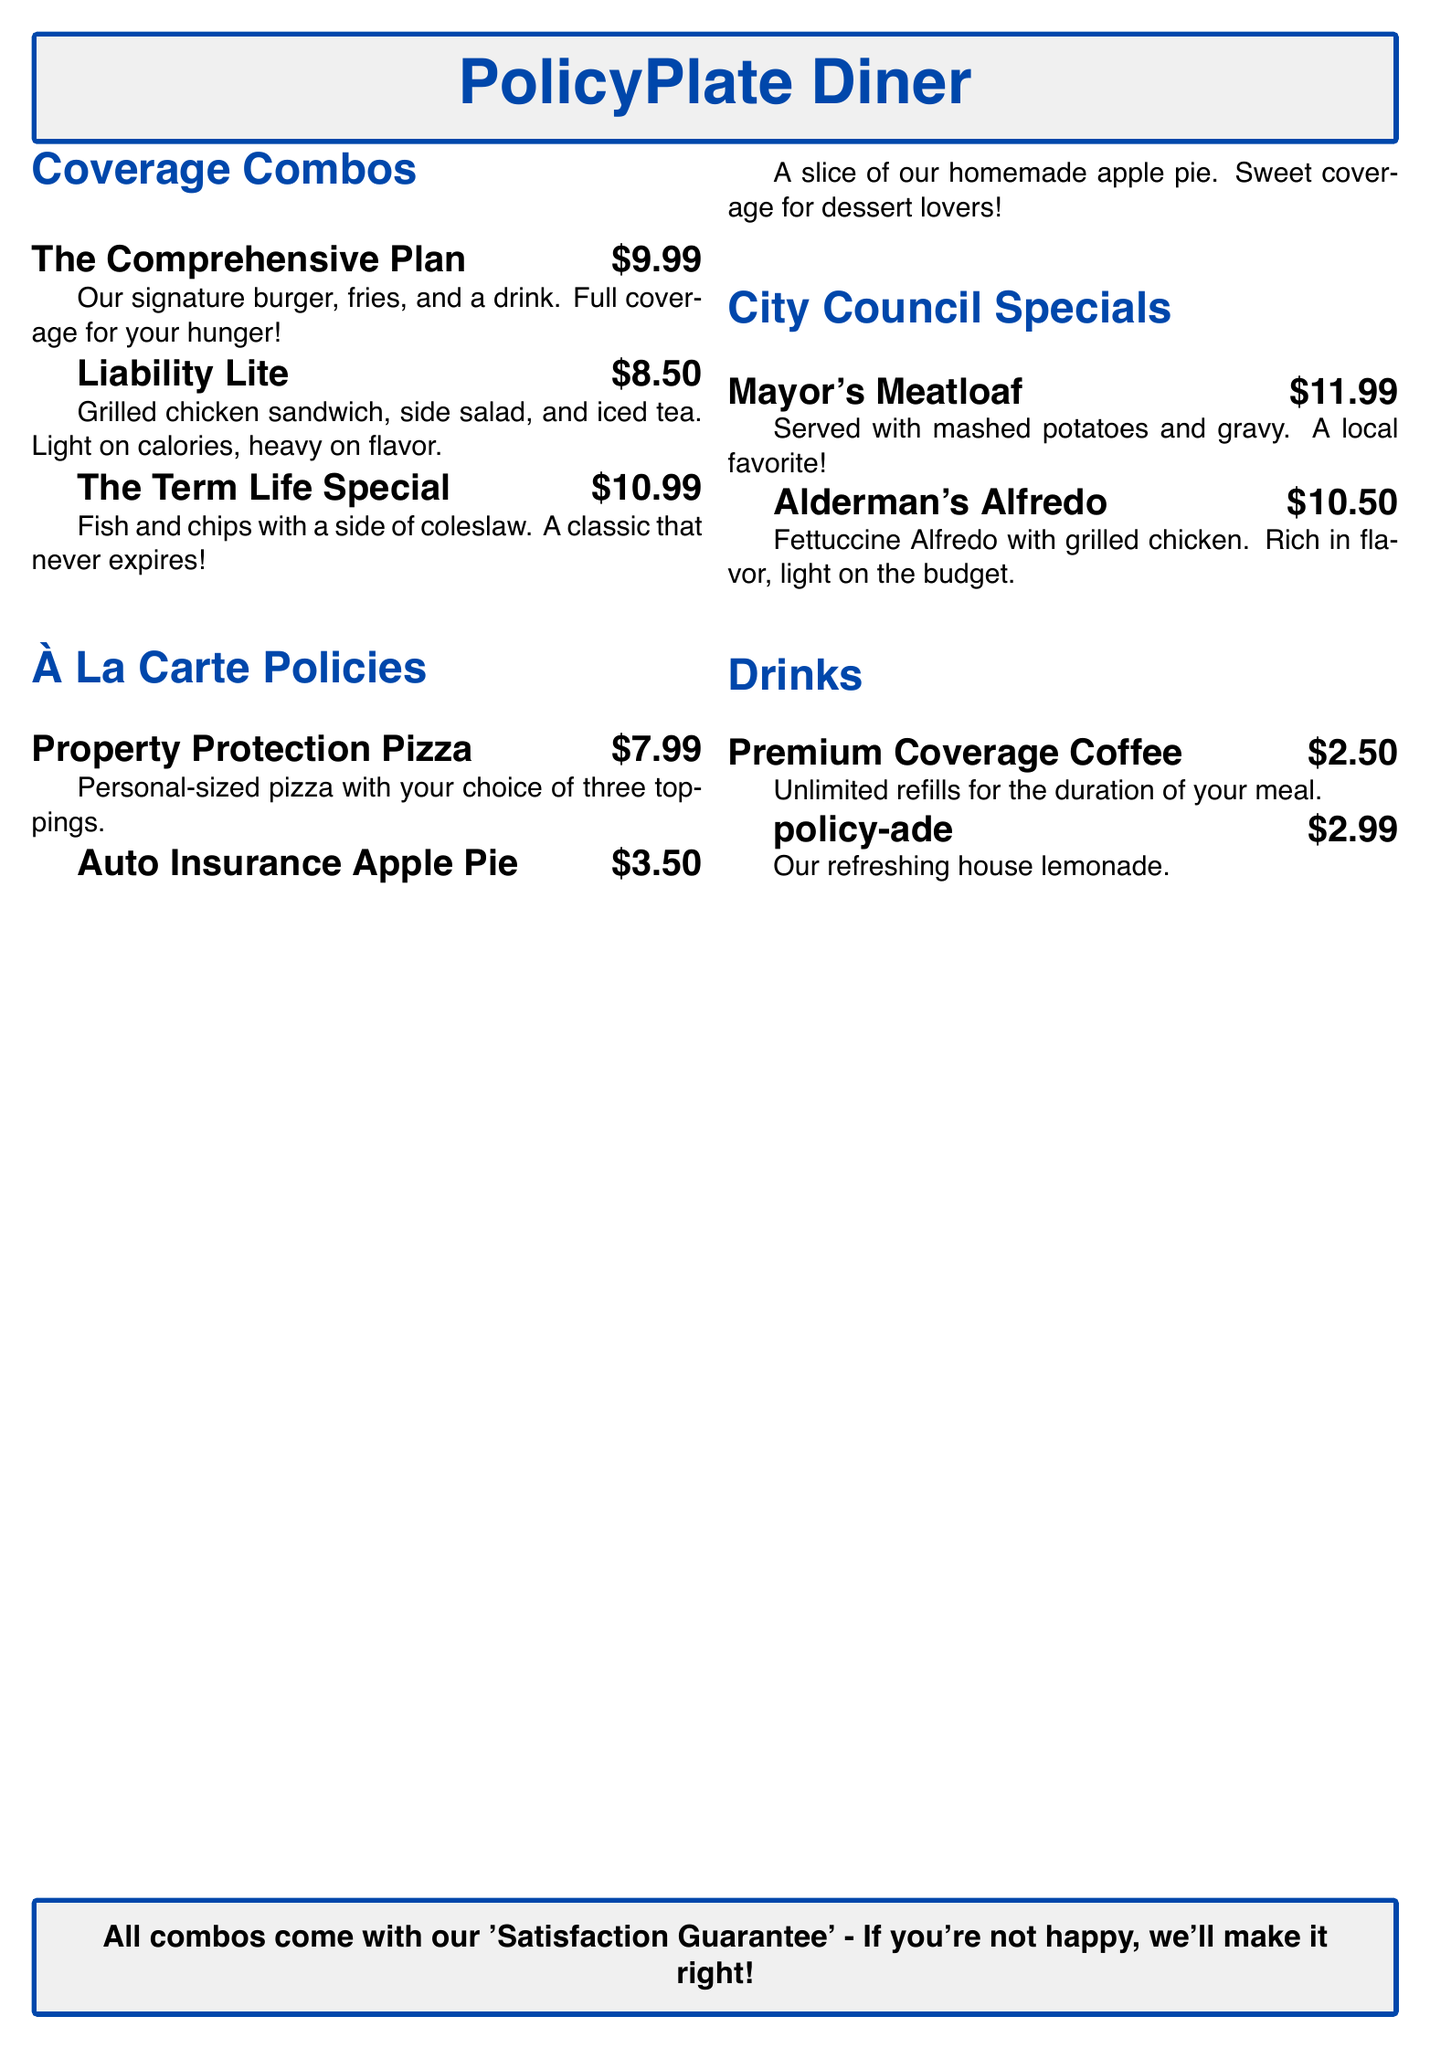What is the name of the diner? The name of the diner is prominently featured at the top of the menu in a large font.
Answer: PolicyPlate Diner What is the price of The Comprehensive Plan combo? The price is listed next to the description of the combo meal.
Answer: $9.99 How many toppings are allowed on the Property Protection Pizza? The number of toppings is specified in the description of the menu item.
Answer: three What is included in the Liability Lite combo? The combo's content is directly mentioned in its description.
Answer: Grilled chicken sandwich, side salad, iced tea What is the total price of the Mayor's Meatloaf meal? The price is stated right after the description of this meal.
Answer: $11.99 Which drink offers unlimited refills? The description of the drink clearly states it offers unlimited refills during the meal.
Answer: Premium Coverage Coffee What dessert is mentioned in the menu? The dessert is listed under À La Carte Policies section.
Answer: Auto Insurance Apple Pie What guarantees are provided with the combo meals? The guarantee is highlighted in a separate box at the bottom of the menu.
Answer: Satisfaction Guarantee What type of pasta is in the Alderman's Alfredo? The type of pasta is specified in the description of the meal.
Answer: Fettuccine 